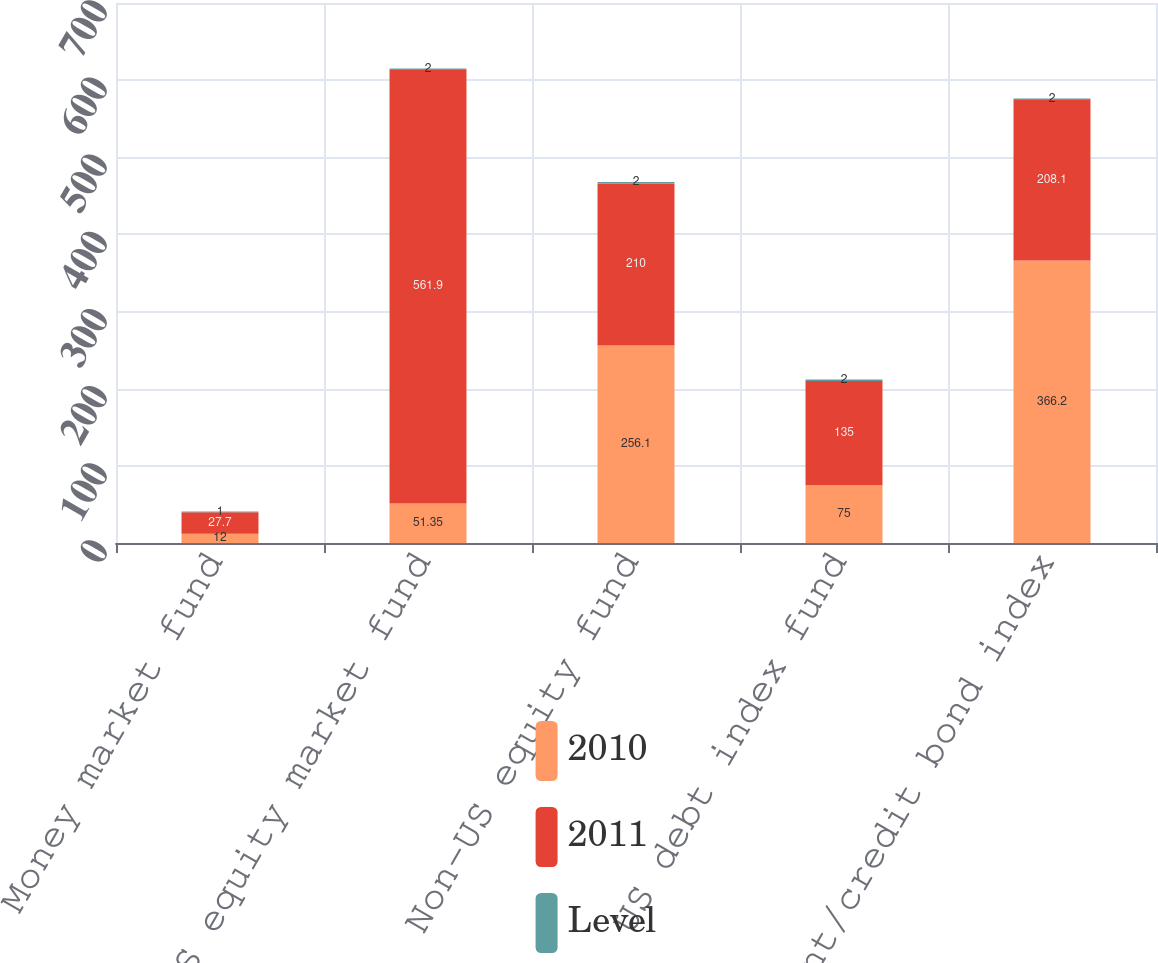<chart> <loc_0><loc_0><loc_500><loc_500><stacked_bar_chart><ecel><fcel>Money market fund<fcel>US equity market fund<fcel>Non-US equity fund<fcel>US debt index fund<fcel>Government/credit bond index<nl><fcel>2010<fcel>12<fcel>51.35<fcel>256.1<fcel>75<fcel>366.2<nl><fcel>2011<fcel>27.7<fcel>561.9<fcel>210<fcel>135<fcel>208.1<nl><fcel>Level<fcel>1<fcel>2<fcel>2<fcel>2<fcel>2<nl></chart> 